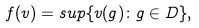Convert formula to latex. <formula><loc_0><loc_0><loc_500><loc_500>f ( v ) = s u p \{ v ( g ) \colon g \in D \} ,</formula> 